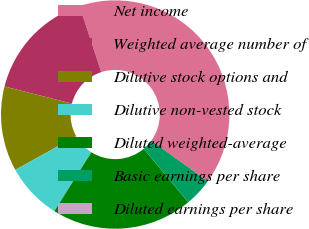Convert chart to OTSL. <chart><loc_0><loc_0><loc_500><loc_500><pie_chart><fcel>Net income<fcel>Weighted average number of<fcel>Dilutive stock options and<fcel>Dilutive non-vested stock<fcel>Diluted weighted-average<fcel>Basic earnings per share<fcel>Diluted earnings per share<nl><fcel>40.0%<fcel>16.0%<fcel>12.0%<fcel>8.0%<fcel>20.0%<fcel>4.0%<fcel>0.0%<nl></chart> 